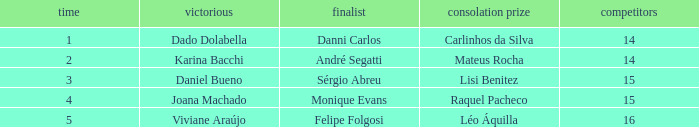How many contestants were there when the runner-up was Monique Evans? 15.0. Could you parse the entire table? {'header': ['time', 'victorious', 'finalist', 'consolation prize', 'competitors'], 'rows': [['1', 'Dado Dolabella', 'Danni Carlos', 'Carlinhos da Silva', '14'], ['2', 'Karina Bacchi', 'André Segatti', 'Mateus Rocha', '14'], ['3', 'Daniel Bueno', 'Sérgio Abreu', 'Lisi Benitez', '15'], ['4', 'Joana Machado', 'Monique Evans', 'Raquel Pacheco', '15'], ['5', 'Viviane Araújo', 'Felipe Folgosi', 'Léo Áquilla', '16']]} 